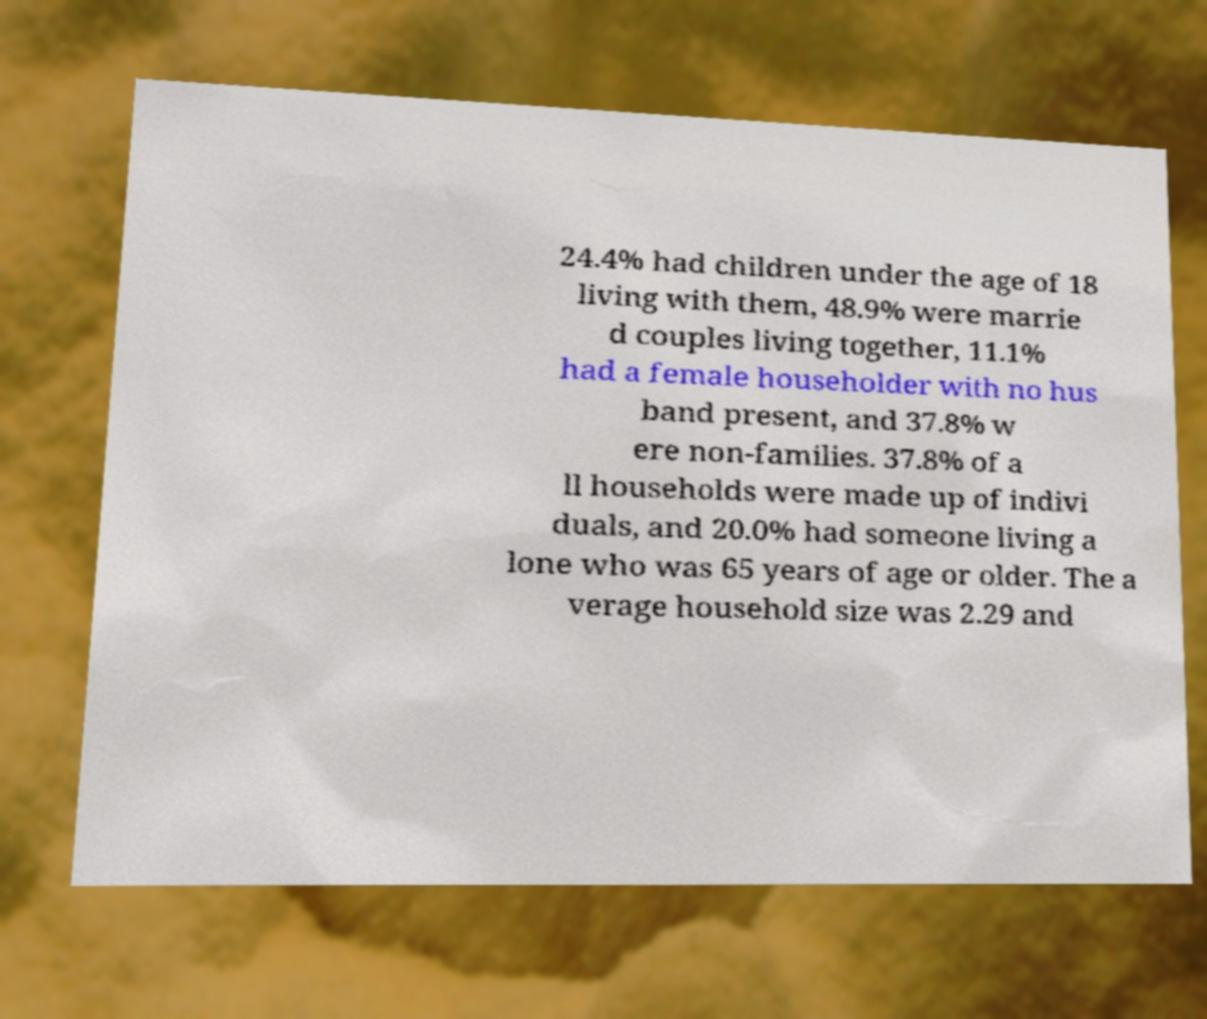Can you read and provide the text displayed in the image?This photo seems to have some interesting text. Can you extract and type it out for me? 24.4% had children under the age of 18 living with them, 48.9% were marrie d couples living together, 11.1% had a female householder with no hus band present, and 37.8% w ere non-families. 37.8% of a ll households were made up of indivi duals, and 20.0% had someone living a lone who was 65 years of age or older. The a verage household size was 2.29 and 